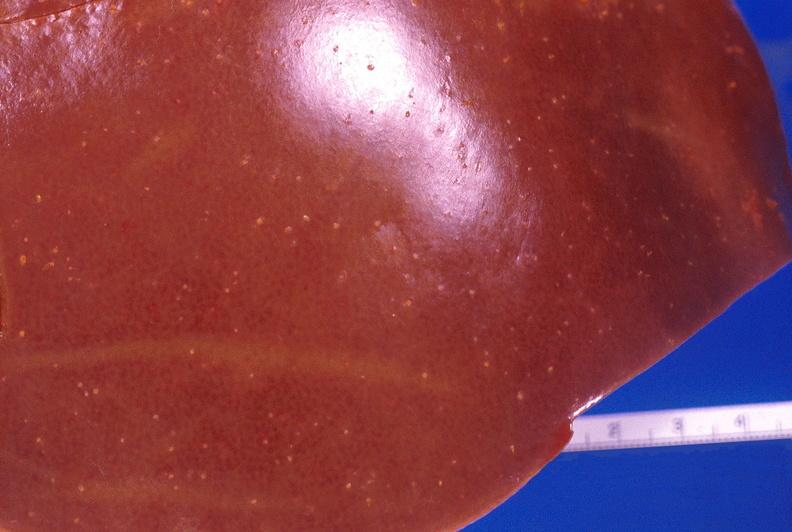what is present?
Answer the question using a single word or phrase. Hepatobiliary 